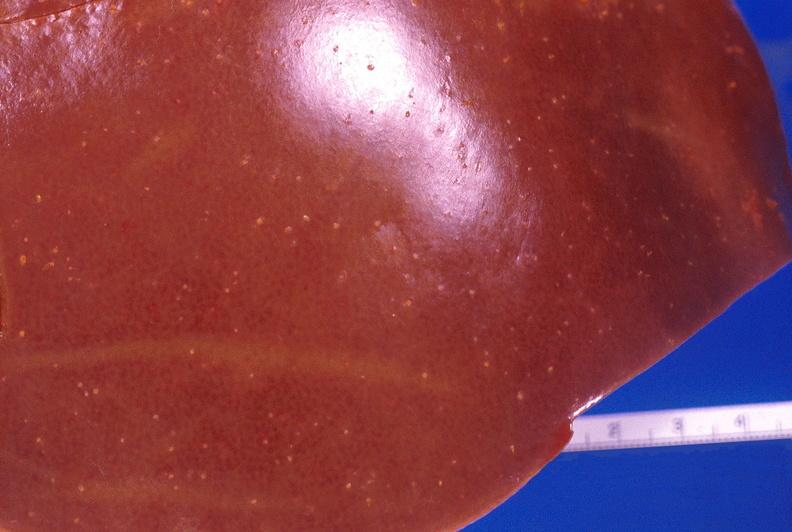what is present?
Answer the question using a single word or phrase. Hepatobiliary 